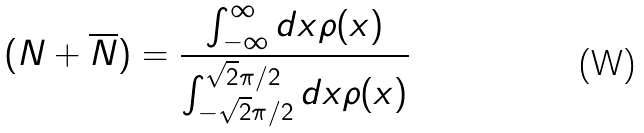<formula> <loc_0><loc_0><loc_500><loc_500>( N + \overline { N } ) = \frac { \int _ { - \infty } ^ { \infty } d x \rho ( x ) } { \int _ { - \sqrt { 2 } \pi / 2 } ^ { \sqrt { 2 } \pi / 2 } d x \rho ( x ) } \</formula> 